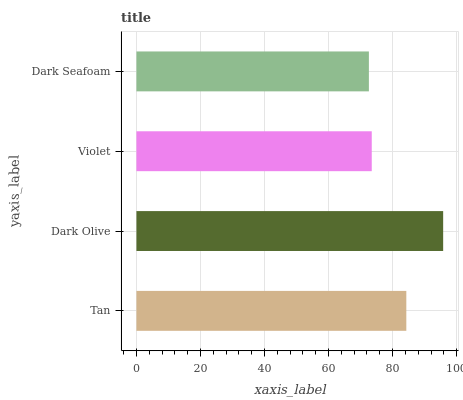Is Dark Seafoam the minimum?
Answer yes or no. Yes. Is Dark Olive the maximum?
Answer yes or no. Yes. Is Violet the minimum?
Answer yes or no. No. Is Violet the maximum?
Answer yes or no. No. Is Dark Olive greater than Violet?
Answer yes or no. Yes. Is Violet less than Dark Olive?
Answer yes or no. Yes. Is Violet greater than Dark Olive?
Answer yes or no. No. Is Dark Olive less than Violet?
Answer yes or no. No. Is Tan the high median?
Answer yes or no. Yes. Is Violet the low median?
Answer yes or no. Yes. Is Dark Seafoam the high median?
Answer yes or no. No. Is Tan the low median?
Answer yes or no. No. 